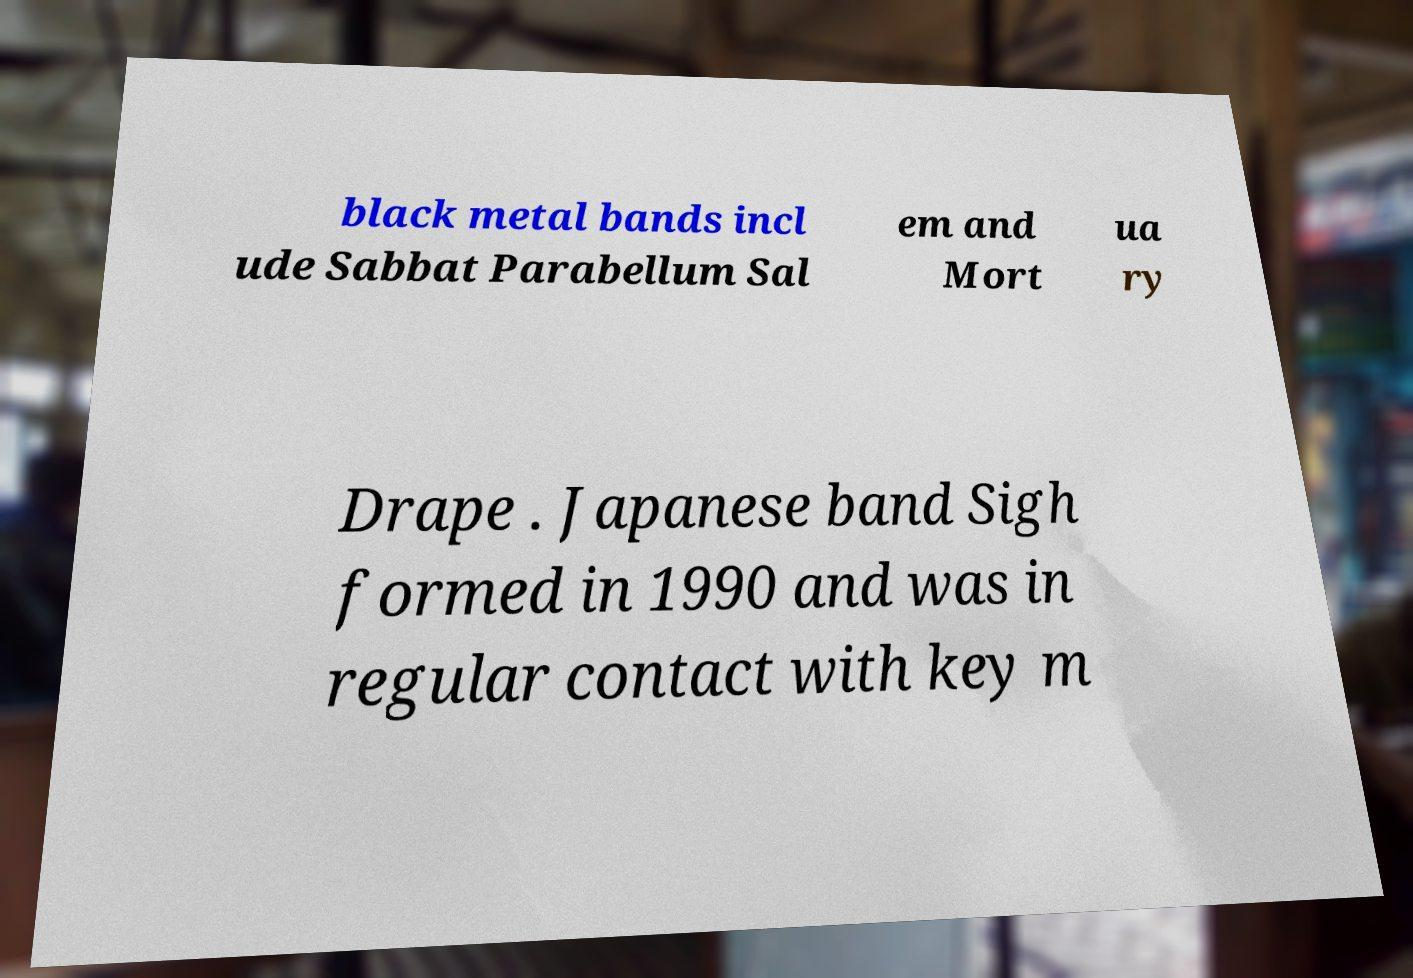What messages or text are displayed in this image? I need them in a readable, typed format. black metal bands incl ude Sabbat Parabellum Sal em and Mort ua ry Drape . Japanese band Sigh formed in 1990 and was in regular contact with key m 